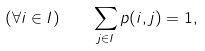Convert formula to latex. <formula><loc_0><loc_0><loc_500><loc_500>( \forall i \in I ) \quad \sum _ { j \in I } p ( i , j ) = 1 ,</formula> 